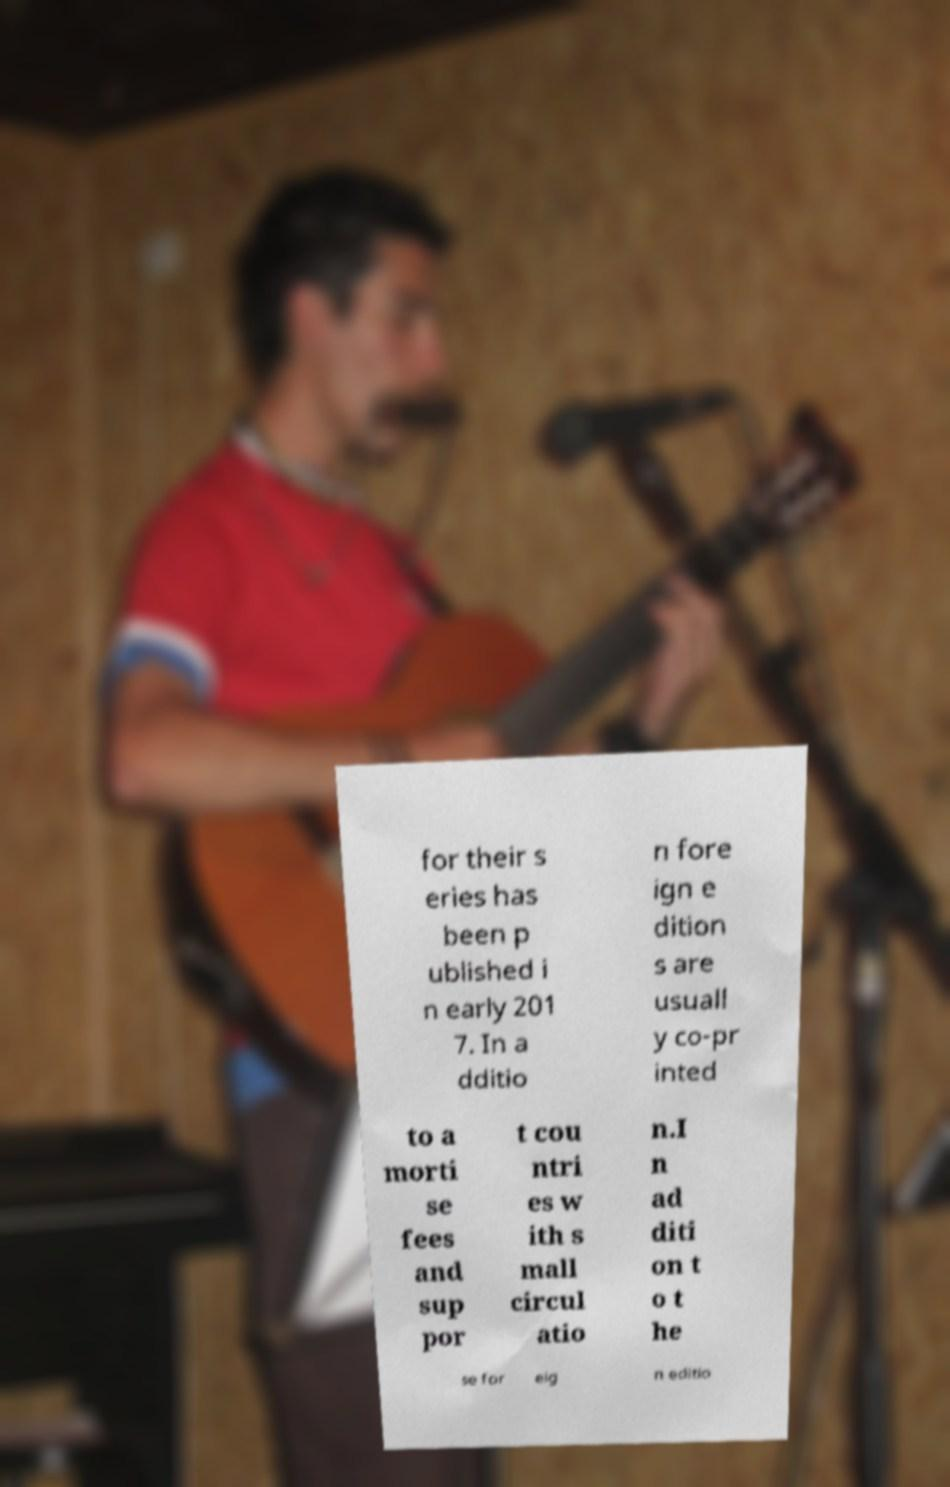Please read and relay the text visible in this image. What does it say? for their s eries has been p ublished i n early 201 7. In a dditio n fore ign e dition s are usuall y co-pr inted to a morti se fees and sup por t cou ntri es w ith s mall circul atio n.I n ad diti on t o t he se for eig n editio 